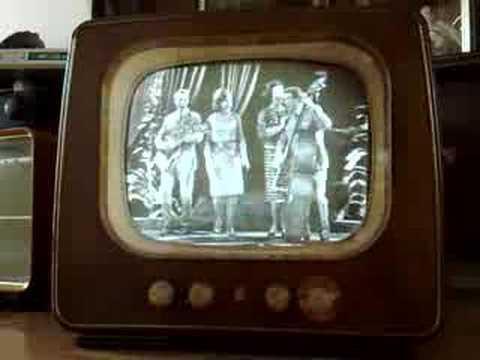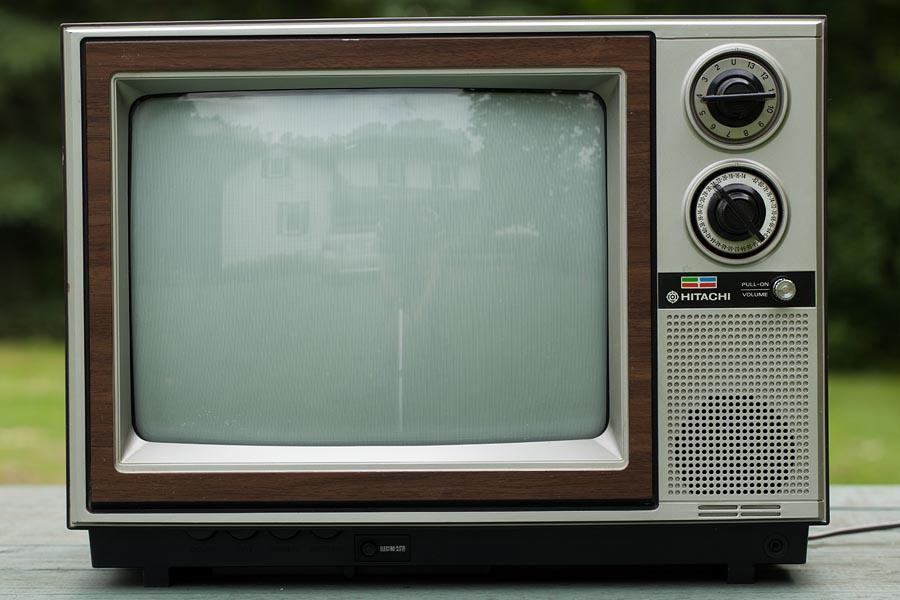The first image is the image on the left, the second image is the image on the right. For the images shown, is this caption "Each image contains a single old-fashioned TV in the foreground, and in one image the TV has a picture on the screen." true? Answer yes or no. Yes. The first image is the image on the left, the second image is the image on the right. For the images displayed, is the sentence "One of the two televisions is showing an image." factually correct? Answer yes or no. Yes. 